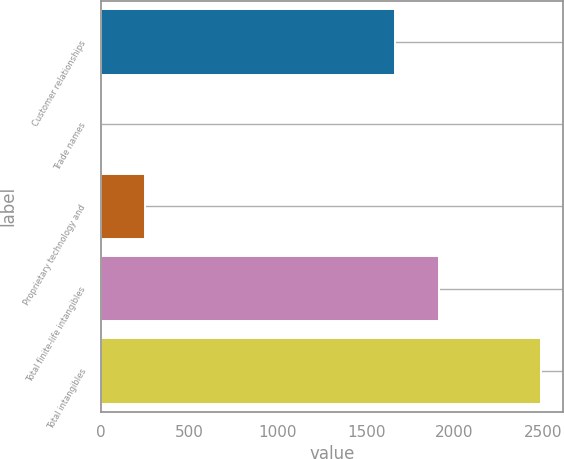<chart> <loc_0><loc_0><loc_500><loc_500><bar_chart><fcel>Customer relationships<fcel>Trade names<fcel>Proprietary technology and<fcel>Total finite-life intangibles<fcel>Total intangibles<nl><fcel>1662.9<fcel>0.6<fcel>249.55<fcel>1911.85<fcel>2490.1<nl></chart> 